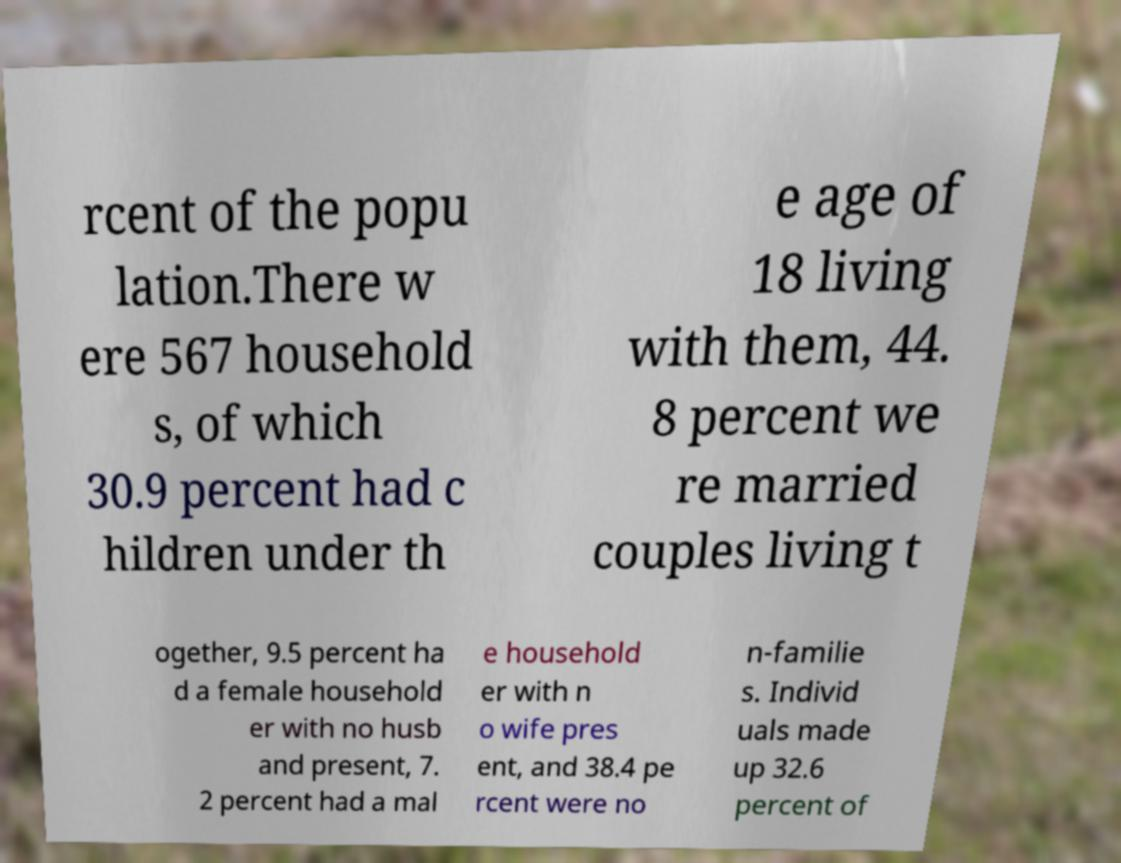For documentation purposes, I need the text within this image transcribed. Could you provide that? rcent of the popu lation.There w ere 567 household s, of which 30.9 percent had c hildren under th e age of 18 living with them, 44. 8 percent we re married couples living t ogether, 9.5 percent ha d a female household er with no husb and present, 7. 2 percent had a mal e household er with n o wife pres ent, and 38.4 pe rcent were no n-familie s. Individ uals made up 32.6 percent of 